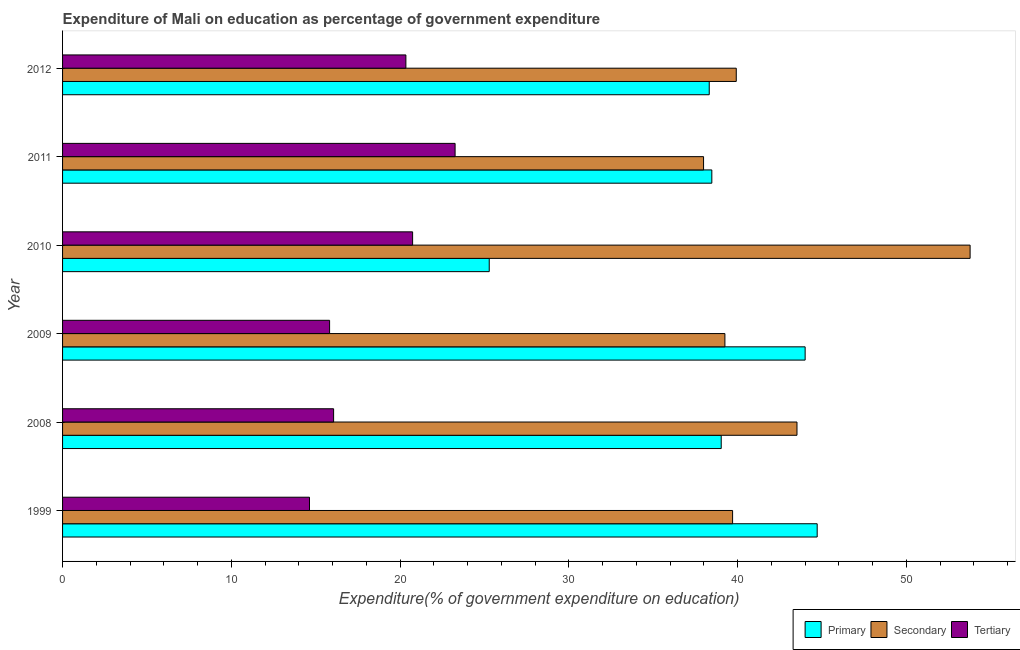How many different coloured bars are there?
Your answer should be compact. 3. What is the label of the 5th group of bars from the top?
Provide a short and direct response. 2008. What is the expenditure on primary education in 1999?
Give a very brief answer. 44.71. Across all years, what is the maximum expenditure on primary education?
Your answer should be very brief. 44.71. Across all years, what is the minimum expenditure on secondary education?
Provide a short and direct response. 37.98. What is the total expenditure on primary education in the graph?
Provide a succinct answer. 229.8. What is the difference between the expenditure on secondary education in 2008 and that in 2011?
Your answer should be very brief. 5.54. What is the difference between the expenditure on tertiary education in 2011 and the expenditure on secondary education in 2012?
Provide a succinct answer. -16.66. What is the average expenditure on primary education per year?
Give a very brief answer. 38.3. In the year 2010, what is the difference between the expenditure on secondary education and expenditure on primary education?
Offer a terse response. 28.49. What is the ratio of the expenditure on primary education in 2008 to that in 2011?
Keep it short and to the point. 1.01. Is the difference between the expenditure on secondary education in 2008 and 2012 greater than the difference between the expenditure on primary education in 2008 and 2012?
Provide a short and direct response. Yes. What is the difference between the highest and the second highest expenditure on primary education?
Your response must be concise. 0.71. What is the difference between the highest and the lowest expenditure on tertiary education?
Your response must be concise. 8.63. In how many years, is the expenditure on tertiary education greater than the average expenditure on tertiary education taken over all years?
Offer a very short reply. 3. Is the sum of the expenditure on primary education in 2008 and 2009 greater than the maximum expenditure on secondary education across all years?
Provide a short and direct response. Yes. What does the 3rd bar from the top in 2011 represents?
Provide a short and direct response. Primary. What does the 3rd bar from the bottom in 2012 represents?
Keep it short and to the point. Tertiary. Is it the case that in every year, the sum of the expenditure on primary education and expenditure on secondary education is greater than the expenditure on tertiary education?
Your answer should be very brief. Yes. How many bars are there?
Offer a terse response. 18. How many years are there in the graph?
Your response must be concise. 6. What is the difference between two consecutive major ticks on the X-axis?
Offer a very short reply. 10. Are the values on the major ticks of X-axis written in scientific E-notation?
Provide a short and direct response. No. How many legend labels are there?
Your answer should be compact. 3. What is the title of the graph?
Your answer should be very brief. Expenditure of Mali on education as percentage of government expenditure. Does "Injury" appear as one of the legend labels in the graph?
Offer a terse response. No. What is the label or title of the X-axis?
Keep it short and to the point. Expenditure(% of government expenditure on education). What is the label or title of the Y-axis?
Your answer should be very brief. Year. What is the Expenditure(% of government expenditure on education) in Primary in 1999?
Make the answer very short. 44.71. What is the Expenditure(% of government expenditure on education) of Secondary in 1999?
Your response must be concise. 39.7. What is the Expenditure(% of government expenditure on education) of Tertiary in 1999?
Ensure brevity in your answer.  14.63. What is the Expenditure(% of government expenditure on education) in Primary in 2008?
Ensure brevity in your answer.  39.03. What is the Expenditure(% of government expenditure on education) in Secondary in 2008?
Offer a terse response. 43.51. What is the Expenditure(% of government expenditure on education) of Tertiary in 2008?
Provide a succinct answer. 16.06. What is the Expenditure(% of government expenditure on education) of Primary in 2009?
Offer a very short reply. 44. What is the Expenditure(% of government expenditure on education) in Secondary in 2009?
Your response must be concise. 39.24. What is the Expenditure(% of government expenditure on education) of Tertiary in 2009?
Provide a succinct answer. 15.82. What is the Expenditure(% of government expenditure on education) in Primary in 2010?
Your response must be concise. 25.28. What is the Expenditure(% of government expenditure on education) of Secondary in 2010?
Give a very brief answer. 53.77. What is the Expenditure(% of government expenditure on education) of Tertiary in 2010?
Your answer should be compact. 20.74. What is the Expenditure(% of government expenditure on education) of Primary in 2011?
Give a very brief answer. 38.47. What is the Expenditure(% of government expenditure on education) in Secondary in 2011?
Provide a succinct answer. 37.98. What is the Expenditure(% of government expenditure on education) in Tertiary in 2011?
Your response must be concise. 23.26. What is the Expenditure(% of government expenditure on education) of Primary in 2012?
Provide a succinct answer. 38.32. What is the Expenditure(% of government expenditure on education) of Secondary in 2012?
Offer a very short reply. 39.92. What is the Expenditure(% of government expenditure on education) in Tertiary in 2012?
Offer a terse response. 20.34. Across all years, what is the maximum Expenditure(% of government expenditure on education) of Primary?
Provide a succinct answer. 44.71. Across all years, what is the maximum Expenditure(% of government expenditure on education) in Secondary?
Provide a short and direct response. 53.77. Across all years, what is the maximum Expenditure(% of government expenditure on education) of Tertiary?
Your response must be concise. 23.26. Across all years, what is the minimum Expenditure(% of government expenditure on education) in Primary?
Your answer should be compact. 25.28. Across all years, what is the minimum Expenditure(% of government expenditure on education) of Secondary?
Offer a terse response. 37.98. Across all years, what is the minimum Expenditure(% of government expenditure on education) in Tertiary?
Ensure brevity in your answer.  14.63. What is the total Expenditure(% of government expenditure on education) in Primary in the graph?
Make the answer very short. 229.8. What is the total Expenditure(% of government expenditure on education) of Secondary in the graph?
Ensure brevity in your answer.  254.13. What is the total Expenditure(% of government expenditure on education) in Tertiary in the graph?
Keep it short and to the point. 110.85. What is the difference between the Expenditure(% of government expenditure on education) in Primary in 1999 and that in 2008?
Make the answer very short. 5.69. What is the difference between the Expenditure(% of government expenditure on education) in Secondary in 1999 and that in 2008?
Offer a very short reply. -3.82. What is the difference between the Expenditure(% of government expenditure on education) in Tertiary in 1999 and that in 2008?
Give a very brief answer. -1.43. What is the difference between the Expenditure(% of government expenditure on education) of Primary in 1999 and that in 2009?
Provide a short and direct response. 0.71. What is the difference between the Expenditure(% of government expenditure on education) in Secondary in 1999 and that in 2009?
Make the answer very short. 0.46. What is the difference between the Expenditure(% of government expenditure on education) in Tertiary in 1999 and that in 2009?
Keep it short and to the point. -1.19. What is the difference between the Expenditure(% of government expenditure on education) in Primary in 1999 and that in 2010?
Offer a very short reply. 19.43. What is the difference between the Expenditure(% of government expenditure on education) in Secondary in 1999 and that in 2010?
Give a very brief answer. -14.07. What is the difference between the Expenditure(% of government expenditure on education) of Tertiary in 1999 and that in 2010?
Provide a succinct answer. -6.11. What is the difference between the Expenditure(% of government expenditure on education) of Primary in 1999 and that in 2011?
Provide a short and direct response. 6.24. What is the difference between the Expenditure(% of government expenditure on education) of Secondary in 1999 and that in 2011?
Provide a succinct answer. 1.72. What is the difference between the Expenditure(% of government expenditure on education) in Tertiary in 1999 and that in 2011?
Your response must be concise. -8.63. What is the difference between the Expenditure(% of government expenditure on education) in Primary in 1999 and that in 2012?
Provide a succinct answer. 6.4. What is the difference between the Expenditure(% of government expenditure on education) of Secondary in 1999 and that in 2012?
Provide a succinct answer. -0.22. What is the difference between the Expenditure(% of government expenditure on education) of Tertiary in 1999 and that in 2012?
Your answer should be very brief. -5.71. What is the difference between the Expenditure(% of government expenditure on education) of Primary in 2008 and that in 2009?
Your response must be concise. -4.97. What is the difference between the Expenditure(% of government expenditure on education) in Secondary in 2008 and that in 2009?
Give a very brief answer. 4.27. What is the difference between the Expenditure(% of government expenditure on education) in Tertiary in 2008 and that in 2009?
Ensure brevity in your answer.  0.24. What is the difference between the Expenditure(% of government expenditure on education) of Primary in 2008 and that in 2010?
Make the answer very short. 13.74. What is the difference between the Expenditure(% of government expenditure on education) of Secondary in 2008 and that in 2010?
Your answer should be very brief. -10.26. What is the difference between the Expenditure(% of government expenditure on education) in Tertiary in 2008 and that in 2010?
Your response must be concise. -4.68. What is the difference between the Expenditure(% of government expenditure on education) of Primary in 2008 and that in 2011?
Offer a terse response. 0.56. What is the difference between the Expenditure(% of government expenditure on education) of Secondary in 2008 and that in 2011?
Your answer should be very brief. 5.54. What is the difference between the Expenditure(% of government expenditure on education) of Tertiary in 2008 and that in 2011?
Make the answer very short. -7.2. What is the difference between the Expenditure(% of government expenditure on education) of Primary in 2008 and that in 2012?
Offer a very short reply. 0.71. What is the difference between the Expenditure(% of government expenditure on education) in Secondary in 2008 and that in 2012?
Provide a succinct answer. 3.6. What is the difference between the Expenditure(% of government expenditure on education) of Tertiary in 2008 and that in 2012?
Ensure brevity in your answer.  -4.28. What is the difference between the Expenditure(% of government expenditure on education) in Primary in 2009 and that in 2010?
Keep it short and to the point. 18.72. What is the difference between the Expenditure(% of government expenditure on education) in Secondary in 2009 and that in 2010?
Your answer should be very brief. -14.53. What is the difference between the Expenditure(% of government expenditure on education) of Tertiary in 2009 and that in 2010?
Your answer should be compact. -4.92. What is the difference between the Expenditure(% of government expenditure on education) in Primary in 2009 and that in 2011?
Your answer should be very brief. 5.53. What is the difference between the Expenditure(% of government expenditure on education) of Secondary in 2009 and that in 2011?
Your answer should be compact. 1.26. What is the difference between the Expenditure(% of government expenditure on education) in Tertiary in 2009 and that in 2011?
Provide a succinct answer. -7.44. What is the difference between the Expenditure(% of government expenditure on education) of Primary in 2009 and that in 2012?
Provide a short and direct response. 5.68. What is the difference between the Expenditure(% of government expenditure on education) of Secondary in 2009 and that in 2012?
Your response must be concise. -0.67. What is the difference between the Expenditure(% of government expenditure on education) of Tertiary in 2009 and that in 2012?
Your answer should be compact. -4.52. What is the difference between the Expenditure(% of government expenditure on education) in Primary in 2010 and that in 2011?
Provide a short and direct response. -13.19. What is the difference between the Expenditure(% of government expenditure on education) of Secondary in 2010 and that in 2011?
Keep it short and to the point. 15.79. What is the difference between the Expenditure(% of government expenditure on education) of Tertiary in 2010 and that in 2011?
Keep it short and to the point. -2.52. What is the difference between the Expenditure(% of government expenditure on education) in Primary in 2010 and that in 2012?
Offer a terse response. -13.03. What is the difference between the Expenditure(% of government expenditure on education) of Secondary in 2010 and that in 2012?
Offer a terse response. 13.86. What is the difference between the Expenditure(% of government expenditure on education) in Tertiary in 2010 and that in 2012?
Give a very brief answer. 0.4. What is the difference between the Expenditure(% of government expenditure on education) in Primary in 2011 and that in 2012?
Make the answer very short. 0.15. What is the difference between the Expenditure(% of government expenditure on education) in Secondary in 2011 and that in 2012?
Your answer should be compact. -1.94. What is the difference between the Expenditure(% of government expenditure on education) in Tertiary in 2011 and that in 2012?
Your answer should be compact. 2.92. What is the difference between the Expenditure(% of government expenditure on education) in Primary in 1999 and the Expenditure(% of government expenditure on education) in Secondary in 2008?
Provide a short and direct response. 1.2. What is the difference between the Expenditure(% of government expenditure on education) of Primary in 1999 and the Expenditure(% of government expenditure on education) of Tertiary in 2008?
Provide a short and direct response. 28.65. What is the difference between the Expenditure(% of government expenditure on education) of Secondary in 1999 and the Expenditure(% of government expenditure on education) of Tertiary in 2008?
Ensure brevity in your answer.  23.64. What is the difference between the Expenditure(% of government expenditure on education) in Primary in 1999 and the Expenditure(% of government expenditure on education) in Secondary in 2009?
Your answer should be very brief. 5.47. What is the difference between the Expenditure(% of government expenditure on education) of Primary in 1999 and the Expenditure(% of government expenditure on education) of Tertiary in 2009?
Offer a very short reply. 28.89. What is the difference between the Expenditure(% of government expenditure on education) in Secondary in 1999 and the Expenditure(% of government expenditure on education) in Tertiary in 2009?
Your answer should be compact. 23.88. What is the difference between the Expenditure(% of government expenditure on education) in Primary in 1999 and the Expenditure(% of government expenditure on education) in Secondary in 2010?
Offer a terse response. -9.06. What is the difference between the Expenditure(% of government expenditure on education) in Primary in 1999 and the Expenditure(% of government expenditure on education) in Tertiary in 2010?
Provide a succinct answer. 23.97. What is the difference between the Expenditure(% of government expenditure on education) in Secondary in 1999 and the Expenditure(% of government expenditure on education) in Tertiary in 2010?
Ensure brevity in your answer.  18.96. What is the difference between the Expenditure(% of government expenditure on education) in Primary in 1999 and the Expenditure(% of government expenditure on education) in Secondary in 2011?
Provide a succinct answer. 6.73. What is the difference between the Expenditure(% of government expenditure on education) in Primary in 1999 and the Expenditure(% of government expenditure on education) in Tertiary in 2011?
Provide a succinct answer. 21.45. What is the difference between the Expenditure(% of government expenditure on education) of Secondary in 1999 and the Expenditure(% of government expenditure on education) of Tertiary in 2011?
Your answer should be compact. 16.44. What is the difference between the Expenditure(% of government expenditure on education) of Primary in 1999 and the Expenditure(% of government expenditure on education) of Secondary in 2012?
Provide a succinct answer. 4.79. What is the difference between the Expenditure(% of government expenditure on education) of Primary in 1999 and the Expenditure(% of government expenditure on education) of Tertiary in 2012?
Your answer should be very brief. 24.37. What is the difference between the Expenditure(% of government expenditure on education) in Secondary in 1999 and the Expenditure(% of government expenditure on education) in Tertiary in 2012?
Give a very brief answer. 19.36. What is the difference between the Expenditure(% of government expenditure on education) in Primary in 2008 and the Expenditure(% of government expenditure on education) in Secondary in 2009?
Give a very brief answer. -0.22. What is the difference between the Expenditure(% of government expenditure on education) of Primary in 2008 and the Expenditure(% of government expenditure on education) of Tertiary in 2009?
Offer a terse response. 23.2. What is the difference between the Expenditure(% of government expenditure on education) of Secondary in 2008 and the Expenditure(% of government expenditure on education) of Tertiary in 2009?
Make the answer very short. 27.69. What is the difference between the Expenditure(% of government expenditure on education) in Primary in 2008 and the Expenditure(% of government expenditure on education) in Secondary in 2010?
Offer a terse response. -14.75. What is the difference between the Expenditure(% of government expenditure on education) in Primary in 2008 and the Expenditure(% of government expenditure on education) in Tertiary in 2010?
Make the answer very short. 18.29. What is the difference between the Expenditure(% of government expenditure on education) in Secondary in 2008 and the Expenditure(% of government expenditure on education) in Tertiary in 2010?
Ensure brevity in your answer.  22.77. What is the difference between the Expenditure(% of government expenditure on education) in Primary in 2008 and the Expenditure(% of government expenditure on education) in Secondary in 2011?
Offer a very short reply. 1.05. What is the difference between the Expenditure(% of government expenditure on education) of Primary in 2008 and the Expenditure(% of government expenditure on education) of Tertiary in 2011?
Your response must be concise. 15.77. What is the difference between the Expenditure(% of government expenditure on education) of Secondary in 2008 and the Expenditure(% of government expenditure on education) of Tertiary in 2011?
Ensure brevity in your answer.  20.26. What is the difference between the Expenditure(% of government expenditure on education) in Primary in 2008 and the Expenditure(% of government expenditure on education) in Secondary in 2012?
Make the answer very short. -0.89. What is the difference between the Expenditure(% of government expenditure on education) of Primary in 2008 and the Expenditure(% of government expenditure on education) of Tertiary in 2012?
Keep it short and to the point. 18.68. What is the difference between the Expenditure(% of government expenditure on education) of Secondary in 2008 and the Expenditure(% of government expenditure on education) of Tertiary in 2012?
Make the answer very short. 23.17. What is the difference between the Expenditure(% of government expenditure on education) in Primary in 2009 and the Expenditure(% of government expenditure on education) in Secondary in 2010?
Keep it short and to the point. -9.78. What is the difference between the Expenditure(% of government expenditure on education) in Primary in 2009 and the Expenditure(% of government expenditure on education) in Tertiary in 2010?
Give a very brief answer. 23.26. What is the difference between the Expenditure(% of government expenditure on education) of Secondary in 2009 and the Expenditure(% of government expenditure on education) of Tertiary in 2010?
Ensure brevity in your answer.  18.5. What is the difference between the Expenditure(% of government expenditure on education) in Primary in 2009 and the Expenditure(% of government expenditure on education) in Secondary in 2011?
Provide a succinct answer. 6.02. What is the difference between the Expenditure(% of government expenditure on education) in Primary in 2009 and the Expenditure(% of government expenditure on education) in Tertiary in 2011?
Provide a short and direct response. 20.74. What is the difference between the Expenditure(% of government expenditure on education) of Secondary in 2009 and the Expenditure(% of government expenditure on education) of Tertiary in 2011?
Ensure brevity in your answer.  15.99. What is the difference between the Expenditure(% of government expenditure on education) of Primary in 2009 and the Expenditure(% of government expenditure on education) of Secondary in 2012?
Provide a succinct answer. 4.08. What is the difference between the Expenditure(% of government expenditure on education) of Primary in 2009 and the Expenditure(% of government expenditure on education) of Tertiary in 2012?
Give a very brief answer. 23.66. What is the difference between the Expenditure(% of government expenditure on education) of Secondary in 2009 and the Expenditure(% of government expenditure on education) of Tertiary in 2012?
Make the answer very short. 18.9. What is the difference between the Expenditure(% of government expenditure on education) of Primary in 2010 and the Expenditure(% of government expenditure on education) of Secondary in 2011?
Provide a succinct answer. -12.7. What is the difference between the Expenditure(% of government expenditure on education) in Primary in 2010 and the Expenditure(% of government expenditure on education) in Tertiary in 2011?
Your response must be concise. 2.02. What is the difference between the Expenditure(% of government expenditure on education) in Secondary in 2010 and the Expenditure(% of government expenditure on education) in Tertiary in 2011?
Give a very brief answer. 30.51. What is the difference between the Expenditure(% of government expenditure on education) of Primary in 2010 and the Expenditure(% of government expenditure on education) of Secondary in 2012?
Provide a short and direct response. -14.64. What is the difference between the Expenditure(% of government expenditure on education) of Primary in 2010 and the Expenditure(% of government expenditure on education) of Tertiary in 2012?
Your answer should be very brief. 4.94. What is the difference between the Expenditure(% of government expenditure on education) of Secondary in 2010 and the Expenditure(% of government expenditure on education) of Tertiary in 2012?
Give a very brief answer. 33.43. What is the difference between the Expenditure(% of government expenditure on education) of Primary in 2011 and the Expenditure(% of government expenditure on education) of Secondary in 2012?
Ensure brevity in your answer.  -1.45. What is the difference between the Expenditure(% of government expenditure on education) of Primary in 2011 and the Expenditure(% of government expenditure on education) of Tertiary in 2012?
Keep it short and to the point. 18.13. What is the difference between the Expenditure(% of government expenditure on education) in Secondary in 2011 and the Expenditure(% of government expenditure on education) in Tertiary in 2012?
Give a very brief answer. 17.64. What is the average Expenditure(% of government expenditure on education) in Primary per year?
Your answer should be compact. 38.3. What is the average Expenditure(% of government expenditure on education) in Secondary per year?
Provide a succinct answer. 42.35. What is the average Expenditure(% of government expenditure on education) of Tertiary per year?
Provide a succinct answer. 18.48. In the year 1999, what is the difference between the Expenditure(% of government expenditure on education) in Primary and Expenditure(% of government expenditure on education) in Secondary?
Your answer should be very brief. 5.01. In the year 1999, what is the difference between the Expenditure(% of government expenditure on education) of Primary and Expenditure(% of government expenditure on education) of Tertiary?
Provide a short and direct response. 30.08. In the year 1999, what is the difference between the Expenditure(% of government expenditure on education) in Secondary and Expenditure(% of government expenditure on education) in Tertiary?
Offer a very short reply. 25.07. In the year 2008, what is the difference between the Expenditure(% of government expenditure on education) of Primary and Expenditure(% of government expenditure on education) of Secondary?
Keep it short and to the point. -4.49. In the year 2008, what is the difference between the Expenditure(% of government expenditure on education) of Primary and Expenditure(% of government expenditure on education) of Tertiary?
Your response must be concise. 22.97. In the year 2008, what is the difference between the Expenditure(% of government expenditure on education) of Secondary and Expenditure(% of government expenditure on education) of Tertiary?
Ensure brevity in your answer.  27.46. In the year 2009, what is the difference between the Expenditure(% of government expenditure on education) in Primary and Expenditure(% of government expenditure on education) in Secondary?
Provide a short and direct response. 4.75. In the year 2009, what is the difference between the Expenditure(% of government expenditure on education) in Primary and Expenditure(% of government expenditure on education) in Tertiary?
Your answer should be compact. 28.18. In the year 2009, what is the difference between the Expenditure(% of government expenditure on education) of Secondary and Expenditure(% of government expenditure on education) of Tertiary?
Ensure brevity in your answer.  23.42. In the year 2010, what is the difference between the Expenditure(% of government expenditure on education) in Primary and Expenditure(% of government expenditure on education) in Secondary?
Offer a terse response. -28.49. In the year 2010, what is the difference between the Expenditure(% of government expenditure on education) of Primary and Expenditure(% of government expenditure on education) of Tertiary?
Your answer should be compact. 4.54. In the year 2010, what is the difference between the Expenditure(% of government expenditure on education) of Secondary and Expenditure(% of government expenditure on education) of Tertiary?
Your response must be concise. 33.03. In the year 2011, what is the difference between the Expenditure(% of government expenditure on education) of Primary and Expenditure(% of government expenditure on education) of Secondary?
Offer a terse response. 0.49. In the year 2011, what is the difference between the Expenditure(% of government expenditure on education) in Primary and Expenditure(% of government expenditure on education) in Tertiary?
Offer a terse response. 15.21. In the year 2011, what is the difference between the Expenditure(% of government expenditure on education) of Secondary and Expenditure(% of government expenditure on education) of Tertiary?
Your response must be concise. 14.72. In the year 2012, what is the difference between the Expenditure(% of government expenditure on education) in Primary and Expenditure(% of government expenditure on education) in Secondary?
Provide a short and direct response. -1.6. In the year 2012, what is the difference between the Expenditure(% of government expenditure on education) of Primary and Expenditure(% of government expenditure on education) of Tertiary?
Your answer should be very brief. 17.97. In the year 2012, what is the difference between the Expenditure(% of government expenditure on education) in Secondary and Expenditure(% of government expenditure on education) in Tertiary?
Keep it short and to the point. 19.57. What is the ratio of the Expenditure(% of government expenditure on education) of Primary in 1999 to that in 2008?
Provide a short and direct response. 1.15. What is the ratio of the Expenditure(% of government expenditure on education) in Secondary in 1999 to that in 2008?
Make the answer very short. 0.91. What is the ratio of the Expenditure(% of government expenditure on education) in Tertiary in 1999 to that in 2008?
Provide a succinct answer. 0.91. What is the ratio of the Expenditure(% of government expenditure on education) of Primary in 1999 to that in 2009?
Give a very brief answer. 1.02. What is the ratio of the Expenditure(% of government expenditure on education) of Secondary in 1999 to that in 2009?
Your answer should be compact. 1.01. What is the ratio of the Expenditure(% of government expenditure on education) of Tertiary in 1999 to that in 2009?
Provide a succinct answer. 0.92. What is the ratio of the Expenditure(% of government expenditure on education) of Primary in 1999 to that in 2010?
Keep it short and to the point. 1.77. What is the ratio of the Expenditure(% of government expenditure on education) in Secondary in 1999 to that in 2010?
Offer a very short reply. 0.74. What is the ratio of the Expenditure(% of government expenditure on education) of Tertiary in 1999 to that in 2010?
Your answer should be very brief. 0.71. What is the ratio of the Expenditure(% of government expenditure on education) in Primary in 1999 to that in 2011?
Make the answer very short. 1.16. What is the ratio of the Expenditure(% of government expenditure on education) of Secondary in 1999 to that in 2011?
Your response must be concise. 1.05. What is the ratio of the Expenditure(% of government expenditure on education) of Tertiary in 1999 to that in 2011?
Ensure brevity in your answer.  0.63. What is the ratio of the Expenditure(% of government expenditure on education) of Primary in 1999 to that in 2012?
Ensure brevity in your answer.  1.17. What is the ratio of the Expenditure(% of government expenditure on education) in Tertiary in 1999 to that in 2012?
Ensure brevity in your answer.  0.72. What is the ratio of the Expenditure(% of government expenditure on education) in Primary in 2008 to that in 2009?
Your answer should be very brief. 0.89. What is the ratio of the Expenditure(% of government expenditure on education) of Secondary in 2008 to that in 2009?
Provide a succinct answer. 1.11. What is the ratio of the Expenditure(% of government expenditure on education) in Primary in 2008 to that in 2010?
Offer a terse response. 1.54. What is the ratio of the Expenditure(% of government expenditure on education) of Secondary in 2008 to that in 2010?
Offer a terse response. 0.81. What is the ratio of the Expenditure(% of government expenditure on education) in Tertiary in 2008 to that in 2010?
Keep it short and to the point. 0.77. What is the ratio of the Expenditure(% of government expenditure on education) of Primary in 2008 to that in 2011?
Provide a short and direct response. 1.01. What is the ratio of the Expenditure(% of government expenditure on education) in Secondary in 2008 to that in 2011?
Keep it short and to the point. 1.15. What is the ratio of the Expenditure(% of government expenditure on education) in Tertiary in 2008 to that in 2011?
Provide a short and direct response. 0.69. What is the ratio of the Expenditure(% of government expenditure on education) in Primary in 2008 to that in 2012?
Make the answer very short. 1.02. What is the ratio of the Expenditure(% of government expenditure on education) of Secondary in 2008 to that in 2012?
Your answer should be very brief. 1.09. What is the ratio of the Expenditure(% of government expenditure on education) of Tertiary in 2008 to that in 2012?
Ensure brevity in your answer.  0.79. What is the ratio of the Expenditure(% of government expenditure on education) of Primary in 2009 to that in 2010?
Make the answer very short. 1.74. What is the ratio of the Expenditure(% of government expenditure on education) of Secondary in 2009 to that in 2010?
Make the answer very short. 0.73. What is the ratio of the Expenditure(% of government expenditure on education) of Tertiary in 2009 to that in 2010?
Ensure brevity in your answer.  0.76. What is the ratio of the Expenditure(% of government expenditure on education) in Primary in 2009 to that in 2011?
Keep it short and to the point. 1.14. What is the ratio of the Expenditure(% of government expenditure on education) in Tertiary in 2009 to that in 2011?
Your answer should be compact. 0.68. What is the ratio of the Expenditure(% of government expenditure on education) in Primary in 2009 to that in 2012?
Your answer should be very brief. 1.15. What is the ratio of the Expenditure(% of government expenditure on education) in Secondary in 2009 to that in 2012?
Give a very brief answer. 0.98. What is the ratio of the Expenditure(% of government expenditure on education) in Tertiary in 2009 to that in 2012?
Provide a succinct answer. 0.78. What is the ratio of the Expenditure(% of government expenditure on education) in Primary in 2010 to that in 2011?
Your answer should be compact. 0.66. What is the ratio of the Expenditure(% of government expenditure on education) of Secondary in 2010 to that in 2011?
Provide a succinct answer. 1.42. What is the ratio of the Expenditure(% of government expenditure on education) in Tertiary in 2010 to that in 2011?
Keep it short and to the point. 0.89. What is the ratio of the Expenditure(% of government expenditure on education) of Primary in 2010 to that in 2012?
Offer a very short reply. 0.66. What is the ratio of the Expenditure(% of government expenditure on education) in Secondary in 2010 to that in 2012?
Offer a terse response. 1.35. What is the ratio of the Expenditure(% of government expenditure on education) in Tertiary in 2010 to that in 2012?
Your answer should be compact. 1.02. What is the ratio of the Expenditure(% of government expenditure on education) in Secondary in 2011 to that in 2012?
Offer a terse response. 0.95. What is the ratio of the Expenditure(% of government expenditure on education) of Tertiary in 2011 to that in 2012?
Your answer should be compact. 1.14. What is the difference between the highest and the second highest Expenditure(% of government expenditure on education) in Primary?
Offer a very short reply. 0.71. What is the difference between the highest and the second highest Expenditure(% of government expenditure on education) of Secondary?
Provide a short and direct response. 10.26. What is the difference between the highest and the second highest Expenditure(% of government expenditure on education) of Tertiary?
Make the answer very short. 2.52. What is the difference between the highest and the lowest Expenditure(% of government expenditure on education) of Primary?
Make the answer very short. 19.43. What is the difference between the highest and the lowest Expenditure(% of government expenditure on education) of Secondary?
Your answer should be very brief. 15.79. What is the difference between the highest and the lowest Expenditure(% of government expenditure on education) of Tertiary?
Make the answer very short. 8.63. 